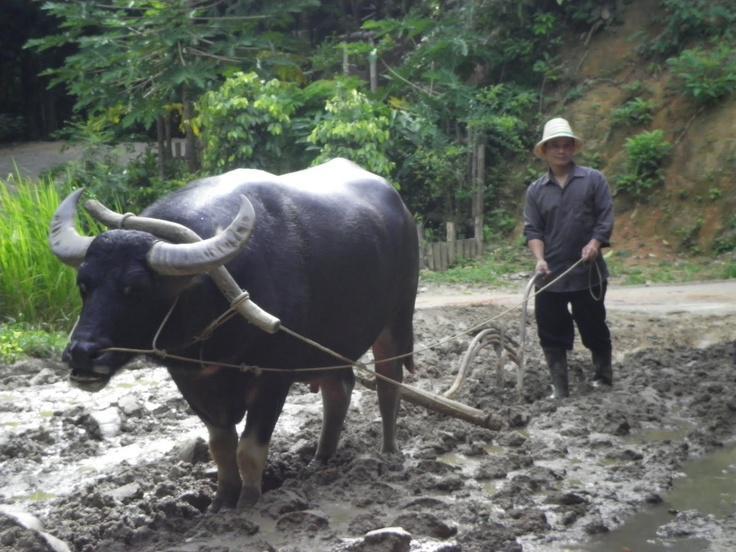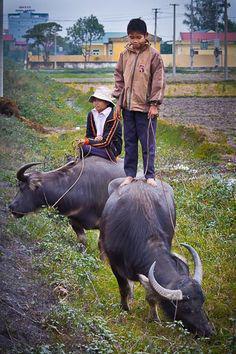The first image is the image on the left, the second image is the image on the right. Evaluate the accuracy of this statement regarding the images: "A man is holding a whip.". Is it true? Answer yes or no. No. The first image is the image on the left, the second image is the image on the right. Examine the images to the left and right. Is the description "One image is of one man with two beast of burden and the other image has one beast with multiple men." accurate? Answer yes or no. No. 